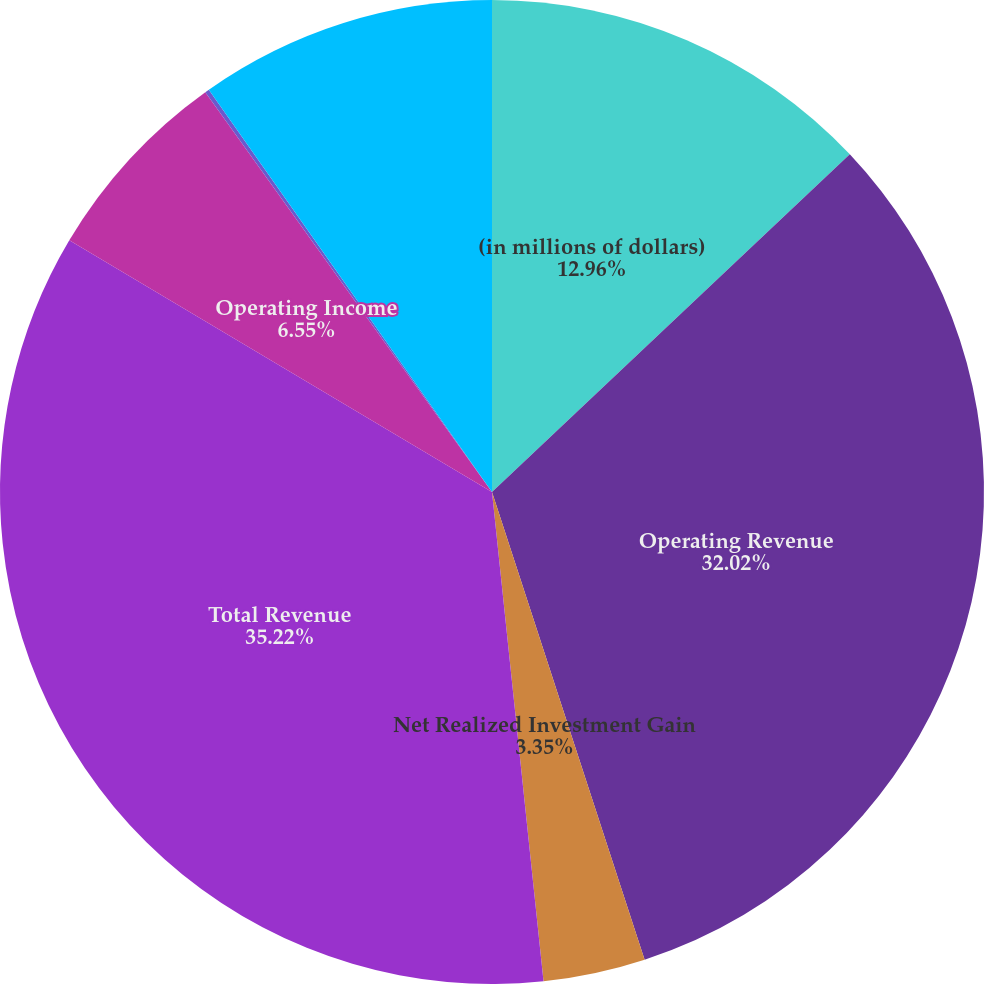Convert chart to OTSL. <chart><loc_0><loc_0><loc_500><loc_500><pie_chart><fcel>(in millions of dollars)<fcel>Operating Revenue<fcel>Net Realized Investment Gain<fcel>Total Revenue<fcel>Operating Income<fcel>Non-operating<fcel>Income Before Income Tax<nl><fcel>12.96%<fcel>32.02%<fcel>3.35%<fcel>35.22%<fcel>6.55%<fcel>0.14%<fcel>9.76%<nl></chart> 